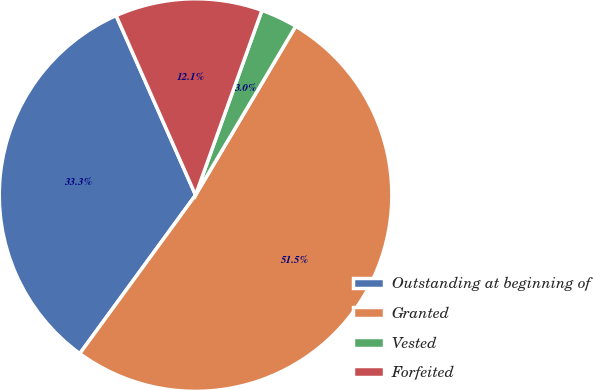Convert chart. <chart><loc_0><loc_0><loc_500><loc_500><pie_chart><fcel>Outstanding at beginning of<fcel>Granted<fcel>Vested<fcel>Forfeited<nl><fcel>33.33%<fcel>51.52%<fcel>3.03%<fcel>12.12%<nl></chart> 